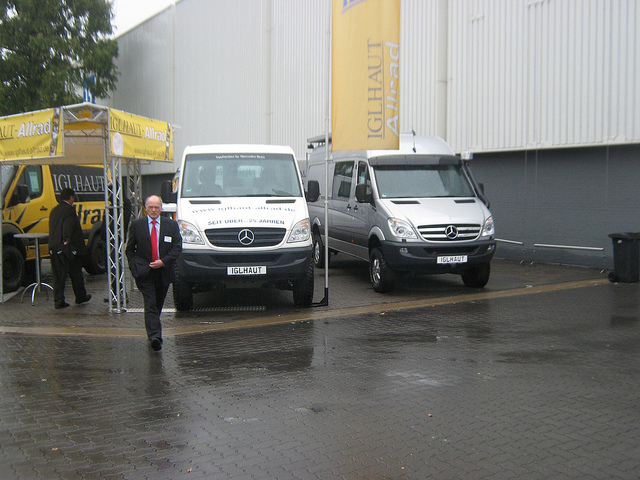Read all the text in this image. IGLHAUT IGLHAUT Allrad IGLHAUT 